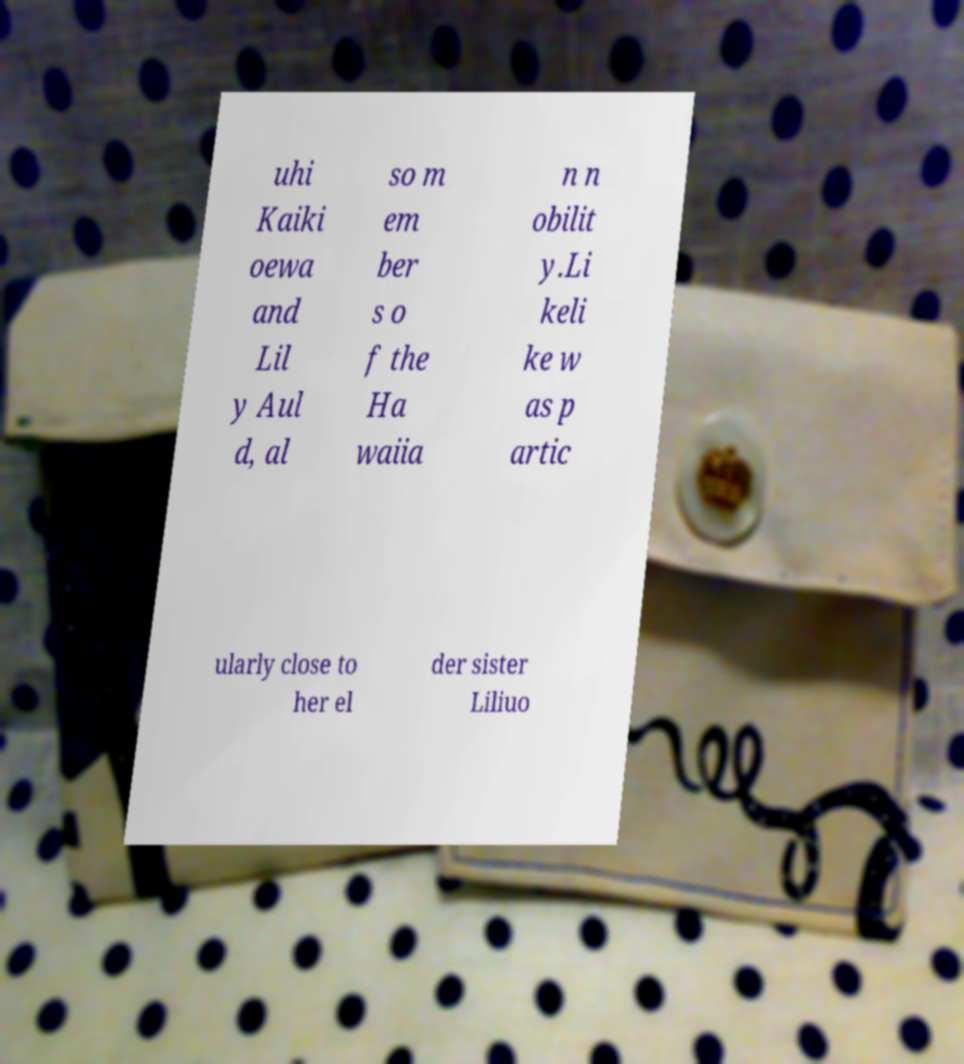Could you extract and type out the text from this image? uhi Kaiki oewa and Lil y Aul d, al so m em ber s o f the Ha waiia n n obilit y.Li keli ke w as p artic ularly close to her el der sister Liliuo 